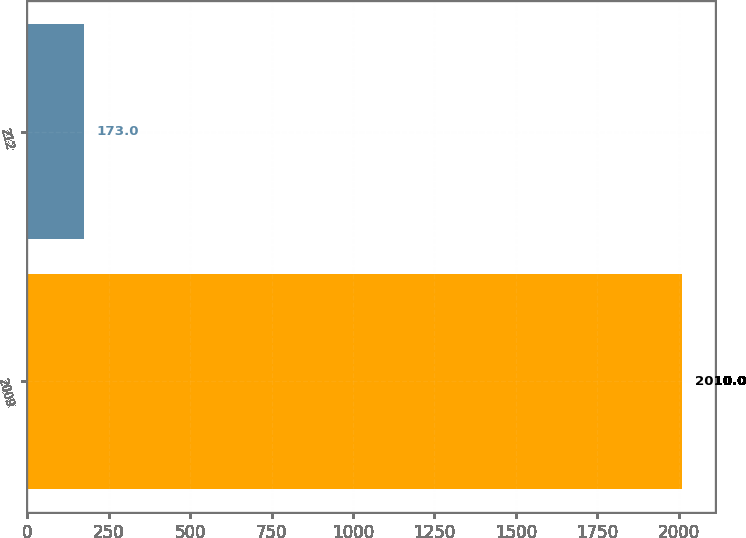Convert chart to OTSL. <chart><loc_0><loc_0><loc_500><loc_500><bar_chart><fcel>2009<fcel>212<nl><fcel>2010<fcel>173<nl></chart> 